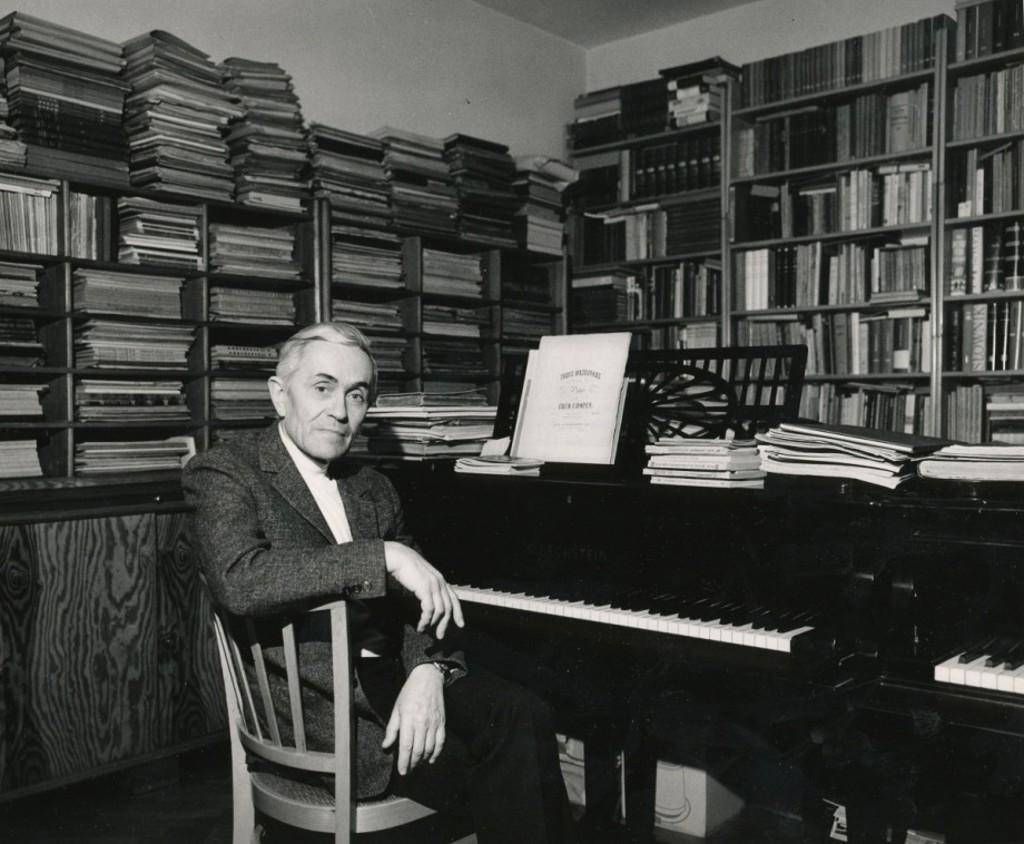What is the man in the image doing? The man is sitting in a chair. Where is the man located in relation to the table? The man is in front of a table. What can be found on the table? The table has books on it. What other furniture is present in the image? There is a bookshelf in the image. How far away is the hydrant from the man in the image? There is no hydrant present in the image, so it is not possible to determine its distance from the man. 